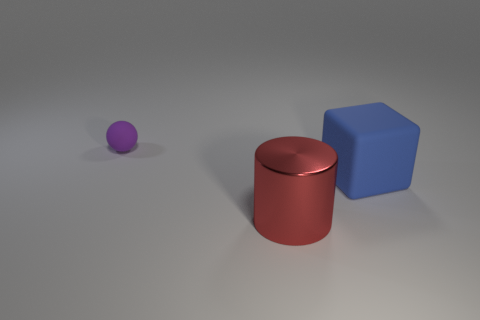Is there anything else that is made of the same material as the large cylinder?
Your answer should be very brief. No. How many big metallic things have the same color as the rubber sphere?
Your response must be concise. 0. There is a ball that is behind the metal thing; is its size the same as the rubber object in front of the purple rubber ball?
Provide a succinct answer. No. There is a red cylinder; is it the same size as the rubber object in front of the ball?
Your response must be concise. Yes. What is the size of the blue rubber block?
Your answer should be compact. Large. There is a small object that is the same material as the big blue thing; what color is it?
Give a very brief answer. Purple. How many small things have the same material as the red cylinder?
Keep it short and to the point. 0. How many objects are large matte blocks or matte things on the right side of the purple rubber sphere?
Provide a short and direct response. 1. Are the large thing to the left of the blue object and the big blue cube made of the same material?
Give a very brief answer. No. There is a shiny cylinder that is the same size as the blue rubber object; what is its color?
Make the answer very short. Red. 